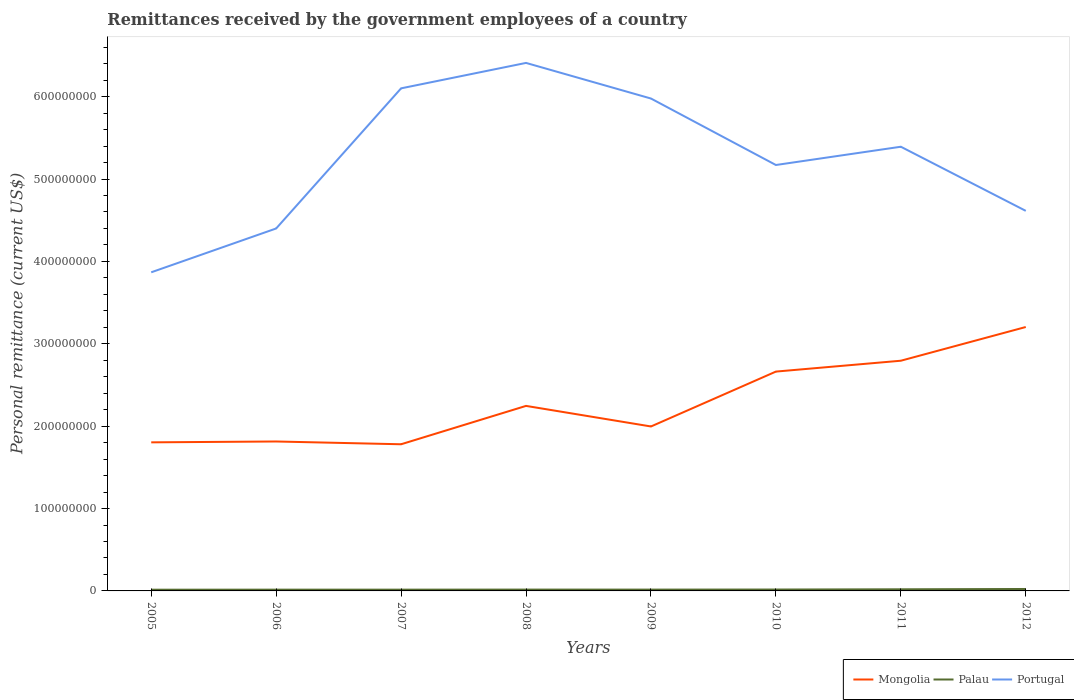How many different coloured lines are there?
Your response must be concise. 3. Across all years, what is the maximum remittances received by the government employees in Palau?
Your answer should be compact. 1.47e+06. What is the total remittances received by the government employees in Mongolia in the graph?
Give a very brief answer. 3.36e+06. What is the difference between the highest and the second highest remittances received by the government employees in Portugal?
Your answer should be compact. 2.54e+08. Is the remittances received by the government employees in Mongolia strictly greater than the remittances received by the government employees in Palau over the years?
Offer a terse response. No. What is the difference between two consecutive major ticks on the Y-axis?
Offer a terse response. 1.00e+08. Are the values on the major ticks of Y-axis written in scientific E-notation?
Offer a very short reply. No. Where does the legend appear in the graph?
Ensure brevity in your answer.  Bottom right. What is the title of the graph?
Keep it short and to the point. Remittances received by the government employees of a country. What is the label or title of the Y-axis?
Provide a short and direct response. Personal remittance (current US$). What is the Personal remittance (current US$) in Mongolia in 2005?
Provide a short and direct response. 1.80e+08. What is the Personal remittance (current US$) of Palau in 2005?
Offer a very short reply. 1.47e+06. What is the Personal remittance (current US$) of Portugal in 2005?
Make the answer very short. 3.87e+08. What is the Personal remittance (current US$) in Mongolia in 2006?
Offer a terse response. 1.81e+08. What is the Personal remittance (current US$) of Palau in 2006?
Make the answer very short. 1.54e+06. What is the Personal remittance (current US$) of Portugal in 2006?
Provide a short and direct response. 4.40e+08. What is the Personal remittance (current US$) of Mongolia in 2007?
Keep it short and to the point. 1.78e+08. What is the Personal remittance (current US$) in Palau in 2007?
Ensure brevity in your answer.  1.53e+06. What is the Personal remittance (current US$) in Portugal in 2007?
Your answer should be compact. 6.10e+08. What is the Personal remittance (current US$) in Mongolia in 2008?
Your answer should be very brief. 2.25e+08. What is the Personal remittance (current US$) of Palau in 2008?
Give a very brief answer. 1.60e+06. What is the Personal remittance (current US$) in Portugal in 2008?
Provide a succinct answer. 6.41e+08. What is the Personal remittance (current US$) of Mongolia in 2009?
Your response must be concise. 2.00e+08. What is the Personal remittance (current US$) in Palau in 2009?
Offer a terse response. 1.59e+06. What is the Personal remittance (current US$) of Portugal in 2009?
Your answer should be compact. 5.98e+08. What is the Personal remittance (current US$) of Mongolia in 2010?
Offer a terse response. 2.66e+08. What is the Personal remittance (current US$) of Palau in 2010?
Ensure brevity in your answer.  1.69e+06. What is the Personal remittance (current US$) of Portugal in 2010?
Your answer should be compact. 5.17e+08. What is the Personal remittance (current US$) of Mongolia in 2011?
Make the answer very short. 2.79e+08. What is the Personal remittance (current US$) in Palau in 2011?
Your response must be concise. 1.97e+06. What is the Personal remittance (current US$) of Portugal in 2011?
Provide a succinct answer. 5.39e+08. What is the Personal remittance (current US$) of Mongolia in 2012?
Your answer should be compact. 3.20e+08. What is the Personal remittance (current US$) of Palau in 2012?
Your response must be concise. 2.36e+06. What is the Personal remittance (current US$) in Portugal in 2012?
Your response must be concise. 4.61e+08. Across all years, what is the maximum Personal remittance (current US$) in Mongolia?
Your answer should be compact. 3.20e+08. Across all years, what is the maximum Personal remittance (current US$) of Palau?
Ensure brevity in your answer.  2.36e+06. Across all years, what is the maximum Personal remittance (current US$) in Portugal?
Keep it short and to the point. 6.41e+08. Across all years, what is the minimum Personal remittance (current US$) in Mongolia?
Give a very brief answer. 1.78e+08. Across all years, what is the minimum Personal remittance (current US$) of Palau?
Give a very brief answer. 1.47e+06. Across all years, what is the minimum Personal remittance (current US$) of Portugal?
Give a very brief answer. 3.87e+08. What is the total Personal remittance (current US$) of Mongolia in the graph?
Ensure brevity in your answer.  1.83e+09. What is the total Personal remittance (current US$) of Palau in the graph?
Offer a terse response. 1.38e+07. What is the total Personal remittance (current US$) of Portugal in the graph?
Offer a terse response. 4.19e+09. What is the difference between the Personal remittance (current US$) of Mongolia in 2005 and that in 2006?
Your answer should be compact. -1.03e+06. What is the difference between the Personal remittance (current US$) in Palau in 2005 and that in 2006?
Provide a succinct answer. -6.72e+04. What is the difference between the Personal remittance (current US$) in Portugal in 2005 and that in 2006?
Make the answer very short. -5.32e+07. What is the difference between the Personal remittance (current US$) of Mongolia in 2005 and that in 2007?
Provide a short and direct response. 2.33e+06. What is the difference between the Personal remittance (current US$) in Palau in 2005 and that in 2007?
Your answer should be compact. -5.45e+04. What is the difference between the Personal remittance (current US$) in Portugal in 2005 and that in 2007?
Make the answer very short. -2.23e+08. What is the difference between the Personal remittance (current US$) of Mongolia in 2005 and that in 2008?
Your response must be concise. -4.42e+07. What is the difference between the Personal remittance (current US$) in Palau in 2005 and that in 2008?
Give a very brief answer. -1.30e+05. What is the difference between the Personal remittance (current US$) of Portugal in 2005 and that in 2008?
Your answer should be very brief. -2.54e+08. What is the difference between the Personal remittance (current US$) of Mongolia in 2005 and that in 2009?
Keep it short and to the point. -1.93e+07. What is the difference between the Personal remittance (current US$) in Palau in 2005 and that in 2009?
Offer a terse response. -1.16e+05. What is the difference between the Personal remittance (current US$) in Portugal in 2005 and that in 2009?
Give a very brief answer. -2.11e+08. What is the difference between the Personal remittance (current US$) of Mongolia in 2005 and that in 2010?
Give a very brief answer. -8.59e+07. What is the difference between the Personal remittance (current US$) in Palau in 2005 and that in 2010?
Ensure brevity in your answer.  -2.10e+05. What is the difference between the Personal remittance (current US$) in Portugal in 2005 and that in 2010?
Provide a short and direct response. -1.30e+08. What is the difference between the Personal remittance (current US$) of Mongolia in 2005 and that in 2011?
Offer a very short reply. -9.91e+07. What is the difference between the Personal remittance (current US$) in Palau in 2005 and that in 2011?
Provide a succinct answer. -4.92e+05. What is the difference between the Personal remittance (current US$) in Portugal in 2005 and that in 2011?
Provide a succinct answer. -1.52e+08. What is the difference between the Personal remittance (current US$) in Mongolia in 2005 and that in 2012?
Make the answer very short. -1.40e+08. What is the difference between the Personal remittance (current US$) in Palau in 2005 and that in 2012?
Ensure brevity in your answer.  -8.85e+05. What is the difference between the Personal remittance (current US$) of Portugal in 2005 and that in 2012?
Your answer should be compact. -7.46e+07. What is the difference between the Personal remittance (current US$) in Mongolia in 2006 and that in 2007?
Give a very brief answer. 3.36e+06. What is the difference between the Personal remittance (current US$) in Palau in 2006 and that in 2007?
Provide a short and direct response. 1.27e+04. What is the difference between the Personal remittance (current US$) in Portugal in 2006 and that in 2007?
Keep it short and to the point. -1.70e+08. What is the difference between the Personal remittance (current US$) of Mongolia in 2006 and that in 2008?
Provide a short and direct response. -4.32e+07. What is the difference between the Personal remittance (current US$) in Palau in 2006 and that in 2008?
Provide a short and direct response. -6.25e+04. What is the difference between the Personal remittance (current US$) in Portugal in 2006 and that in 2008?
Your answer should be compact. -2.01e+08. What is the difference between the Personal remittance (current US$) of Mongolia in 2006 and that in 2009?
Your answer should be very brief. -1.82e+07. What is the difference between the Personal remittance (current US$) of Palau in 2006 and that in 2009?
Give a very brief answer. -4.83e+04. What is the difference between the Personal remittance (current US$) of Portugal in 2006 and that in 2009?
Make the answer very short. -1.58e+08. What is the difference between the Personal remittance (current US$) in Mongolia in 2006 and that in 2010?
Your response must be concise. -8.49e+07. What is the difference between the Personal remittance (current US$) of Palau in 2006 and that in 2010?
Your answer should be very brief. -1.43e+05. What is the difference between the Personal remittance (current US$) of Portugal in 2006 and that in 2010?
Offer a terse response. -7.71e+07. What is the difference between the Personal remittance (current US$) of Mongolia in 2006 and that in 2011?
Offer a terse response. -9.80e+07. What is the difference between the Personal remittance (current US$) in Palau in 2006 and that in 2011?
Keep it short and to the point. -4.25e+05. What is the difference between the Personal remittance (current US$) in Portugal in 2006 and that in 2011?
Keep it short and to the point. -9.92e+07. What is the difference between the Personal remittance (current US$) of Mongolia in 2006 and that in 2012?
Your answer should be very brief. -1.39e+08. What is the difference between the Personal remittance (current US$) in Palau in 2006 and that in 2012?
Make the answer very short. -8.18e+05. What is the difference between the Personal remittance (current US$) of Portugal in 2006 and that in 2012?
Your answer should be compact. -2.14e+07. What is the difference between the Personal remittance (current US$) in Mongolia in 2007 and that in 2008?
Give a very brief answer. -4.66e+07. What is the difference between the Personal remittance (current US$) of Palau in 2007 and that in 2008?
Keep it short and to the point. -7.51e+04. What is the difference between the Personal remittance (current US$) in Portugal in 2007 and that in 2008?
Provide a succinct answer. -3.09e+07. What is the difference between the Personal remittance (current US$) in Mongolia in 2007 and that in 2009?
Ensure brevity in your answer.  -2.16e+07. What is the difference between the Personal remittance (current US$) of Palau in 2007 and that in 2009?
Your response must be concise. -6.10e+04. What is the difference between the Personal remittance (current US$) in Portugal in 2007 and that in 2009?
Give a very brief answer. 1.24e+07. What is the difference between the Personal remittance (current US$) of Mongolia in 2007 and that in 2010?
Your response must be concise. -8.82e+07. What is the difference between the Personal remittance (current US$) of Palau in 2007 and that in 2010?
Your answer should be compact. -1.56e+05. What is the difference between the Personal remittance (current US$) in Portugal in 2007 and that in 2010?
Provide a short and direct response. 9.31e+07. What is the difference between the Personal remittance (current US$) of Mongolia in 2007 and that in 2011?
Your answer should be compact. -1.01e+08. What is the difference between the Personal remittance (current US$) in Palau in 2007 and that in 2011?
Offer a very short reply. -4.38e+05. What is the difference between the Personal remittance (current US$) of Portugal in 2007 and that in 2011?
Give a very brief answer. 7.09e+07. What is the difference between the Personal remittance (current US$) of Mongolia in 2007 and that in 2012?
Your response must be concise. -1.42e+08. What is the difference between the Personal remittance (current US$) in Palau in 2007 and that in 2012?
Offer a very short reply. -8.31e+05. What is the difference between the Personal remittance (current US$) in Portugal in 2007 and that in 2012?
Offer a terse response. 1.49e+08. What is the difference between the Personal remittance (current US$) of Mongolia in 2008 and that in 2009?
Ensure brevity in your answer.  2.50e+07. What is the difference between the Personal remittance (current US$) in Palau in 2008 and that in 2009?
Give a very brief answer. 1.41e+04. What is the difference between the Personal remittance (current US$) of Portugal in 2008 and that in 2009?
Ensure brevity in your answer.  4.32e+07. What is the difference between the Personal remittance (current US$) of Mongolia in 2008 and that in 2010?
Give a very brief answer. -4.16e+07. What is the difference between the Personal remittance (current US$) of Palau in 2008 and that in 2010?
Ensure brevity in your answer.  -8.08e+04. What is the difference between the Personal remittance (current US$) of Portugal in 2008 and that in 2010?
Keep it short and to the point. 1.24e+08. What is the difference between the Personal remittance (current US$) of Mongolia in 2008 and that in 2011?
Provide a short and direct response. -5.48e+07. What is the difference between the Personal remittance (current US$) in Palau in 2008 and that in 2011?
Offer a terse response. -3.63e+05. What is the difference between the Personal remittance (current US$) of Portugal in 2008 and that in 2011?
Provide a short and direct response. 1.02e+08. What is the difference between the Personal remittance (current US$) in Mongolia in 2008 and that in 2012?
Give a very brief answer. -9.58e+07. What is the difference between the Personal remittance (current US$) of Palau in 2008 and that in 2012?
Your answer should be very brief. -7.56e+05. What is the difference between the Personal remittance (current US$) in Portugal in 2008 and that in 2012?
Provide a succinct answer. 1.80e+08. What is the difference between the Personal remittance (current US$) of Mongolia in 2009 and that in 2010?
Provide a succinct answer. -6.66e+07. What is the difference between the Personal remittance (current US$) of Palau in 2009 and that in 2010?
Ensure brevity in your answer.  -9.49e+04. What is the difference between the Personal remittance (current US$) of Portugal in 2009 and that in 2010?
Keep it short and to the point. 8.07e+07. What is the difference between the Personal remittance (current US$) in Mongolia in 2009 and that in 2011?
Give a very brief answer. -7.98e+07. What is the difference between the Personal remittance (current US$) in Palau in 2009 and that in 2011?
Your response must be concise. -3.77e+05. What is the difference between the Personal remittance (current US$) in Portugal in 2009 and that in 2011?
Provide a succinct answer. 5.85e+07. What is the difference between the Personal remittance (current US$) of Mongolia in 2009 and that in 2012?
Ensure brevity in your answer.  -1.21e+08. What is the difference between the Personal remittance (current US$) of Palau in 2009 and that in 2012?
Your answer should be very brief. -7.70e+05. What is the difference between the Personal remittance (current US$) of Portugal in 2009 and that in 2012?
Provide a short and direct response. 1.36e+08. What is the difference between the Personal remittance (current US$) of Mongolia in 2010 and that in 2011?
Keep it short and to the point. -1.32e+07. What is the difference between the Personal remittance (current US$) in Palau in 2010 and that in 2011?
Provide a succinct answer. -2.82e+05. What is the difference between the Personal remittance (current US$) in Portugal in 2010 and that in 2011?
Your answer should be compact. -2.22e+07. What is the difference between the Personal remittance (current US$) of Mongolia in 2010 and that in 2012?
Keep it short and to the point. -5.41e+07. What is the difference between the Personal remittance (current US$) of Palau in 2010 and that in 2012?
Ensure brevity in your answer.  -6.75e+05. What is the difference between the Personal remittance (current US$) in Portugal in 2010 and that in 2012?
Provide a short and direct response. 5.57e+07. What is the difference between the Personal remittance (current US$) of Mongolia in 2011 and that in 2012?
Give a very brief answer. -4.09e+07. What is the difference between the Personal remittance (current US$) in Palau in 2011 and that in 2012?
Your answer should be compact. -3.93e+05. What is the difference between the Personal remittance (current US$) in Portugal in 2011 and that in 2012?
Give a very brief answer. 7.78e+07. What is the difference between the Personal remittance (current US$) in Mongolia in 2005 and the Personal remittance (current US$) in Palau in 2006?
Provide a succinct answer. 1.79e+08. What is the difference between the Personal remittance (current US$) of Mongolia in 2005 and the Personal remittance (current US$) of Portugal in 2006?
Give a very brief answer. -2.60e+08. What is the difference between the Personal remittance (current US$) in Palau in 2005 and the Personal remittance (current US$) in Portugal in 2006?
Ensure brevity in your answer.  -4.38e+08. What is the difference between the Personal remittance (current US$) of Mongolia in 2005 and the Personal remittance (current US$) of Palau in 2007?
Offer a very short reply. 1.79e+08. What is the difference between the Personal remittance (current US$) in Mongolia in 2005 and the Personal remittance (current US$) in Portugal in 2007?
Offer a terse response. -4.30e+08. What is the difference between the Personal remittance (current US$) of Palau in 2005 and the Personal remittance (current US$) of Portugal in 2007?
Offer a terse response. -6.09e+08. What is the difference between the Personal remittance (current US$) in Mongolia in 2005 and the Personal remittance (current US$) in Palau in 2008?
Provide a short and direct response. 1.79e+08. What is the difference between the Personal remittance (current US$) in Mongolia in 2005 and the Personal remittance (current US$) in Portugal in 2008?
Give a very brief answer. -4.61e+08. What is the difference between the Personal remittance (current US$) in Palau in 2005 and the Personal remittance (current US$) in Portugal in 2008?
Give a very brief answer. -6.39e+08. What is the difference between the Personal remittance (current US$) in Mongolia in 2005 and the Personal remittance (current US$) in Palau in 2009?
Provide a succinct answer. 1.79e+08. What is the difference between the Personal remittance (current US$) in Mongolia in 2005 and the Personal remittance (current US$) in Portugal in 2009?
Provide a succinct answer. -4.17e+08. What is the difference between the Personal remittance (current US$) in Palau in 2005 and the Personal remittance (current US$) in Portugal in 2009?
Your answer should be very brief. -5.96e+08. What is the difference between the Personal remittance (current US$) in Mongolia in 2005 and the Personal remittance (current US$) in Palau in 2010?
Offer a terse response. 1.79e+08. What is the difference between the Personal remittance (current US$) of Mongolia in 2005 and the Personal remittance (current US$) of Portugal in 2010?
Give a very brief answer. -3.37e+08. What is the difference between the Personal remittance (current US$) in Palau in 2005 and the Personal remittance (current US$) in Portugal in 2010?
Your answer should be very brief. -5.16e+08. What is the difference between the Personal remittance (current US$) of Mongolia in 2005 and the Personal remittance (current US$) of Palau in 2011?
Your answer should be compact. 1.78e+08. What is the difference between the Personal remittance (current US$) of Mongolia in 2005 and the Personal remittance (current US$) of Portugal in 2011?
Offer a very short reply. -3.59e+08. What is the difference between the Personal remittance (current US$) of Palau in 2005 and the Personal remittance (current US$) of Portugal in 2011?
Provide a succinct answer. -5.38e+08. What is the difference between the Personal remittance (current US$) of Mongolia in 2005 and the Personal remittance (current US$) of Palau in 2012?
Offer a terse response. 1.78e+08. What is the difference between the Personal remittance (current US$) of Mongolia in 2005 and the Personal remittance (current US$) of Portugal in 2012?
Ensure brevity in your answer.  -2.81e+08. What is the difference between the Personal remittance (current US$) in Palau in 2005 and the Personal remittance (current US$) in Portugal in 2012?
Offer a very short reply. -4.60e+08. What is the difference between the Personal remittance (current US$) of Mongolia in 2006 and the Personal remittance (current US$) of Palau in 2007?
Ensure brevity in your answer.  1.80e+08. What is the difference between the Personal remittance (current US$) of Mongolia in 2006 and the Personal remittance (current US$) of Portugal in 2007?
Offer a terse response. -4.29e+08. What is the difference between the Personal remittance (current US$) of Palau in 2006 and the Personal remittance (current US$) of Portugal in 2007?
Keep it short and to the point. -6.09e+08. What is the difference between the Personal remittance (current US$) of Mongolia in 2006 and the Personal remittance (current US$) of Palau in 2008?
Your answer should be compact. 1.80e+08. What is the difference between the Personal remittance (current US$) in Mongolia in 2006 and the Personal remittance (current US$) in Portugal in 2008?
Ensure brevity in your answer.  -4.60e+08. What is the difference between the Personal remittance (current US$) in Palau in 2006 and the Personal remittance (current US$) in Portugal in 2008?
Ensure brevity in your answer.  -6.39e+08. What is the difference between the Personal remittance (current US$) in Mongolia in 2006 and the Personal remittance (current US$) in Palau in 2009?
Make the answer very short. 1.80e+08. What is the difference between the Personal remittance (current US$) in Mongolia in 2006 and the Personal remittance (current US$) in Portugal in 2009?
Ensure brevity in your answer.  -4.16e+08. What is the difference between the Personal remittance (current US$) of Palau in 2006 and the Personal remittance (current US$) of Portugal in 2009?
Provide a succinct answer. -5.96e+08. What is the difference between the Personal remittance (current US$) in Mongolia in 2006 and the Personal remittance (current US$) in Palau in 2010?
Your response must be concise. 1.80e+08. What is the difference between the Personal remittance (current US$) in Mongolia in 2006 and the Personal remittance (current US$) in Portugal in 2010?
Give a very brief answer. -3.36e+08. What is the difference between the Personal remittance (current US$) of Palau in 2006 and the Personal remittance (current US$) of Portugal in 2010?
Give a very brief answer. -5.15e+08. What is the difference between the Personal remittance (current US$) of Mongolia in 2006 and the Personal remittance (current US$) of Palau in 2011?
Keep it short and to the point. 1.79e+08. What is the difference between the Personal remittance (current US$) in Mongolia in 2006 and the Personal remittance (current US$) in Portugal in 2011?
Your response must be concise. -3.58e+08. What is the difference between the Personal remittance (current US$) of Palau in 2006 and the Personal remittance (current US$) of Portugal in 2011?
Give a very brief answer. -5.38e+08. What is the difference between the Personal remittance (current US$) in Mongolia in 2006 and the Personal remittance (current US$) in Palau in 2012?
Make the answer very short. 1.79e+08. What is the difference between the Personal remittance (current US$) in Mongolia in 2006 and the Personal remittance (current US$) in Portugal in 2012?
Ensure brevity in your answer.  -2.80e+08. What is the difference between the Personal remittance (current US$) in Palau in 2006 and the Personal remittance (current US$) in Portugal in 2012?
Provide a short and direct response. -4.60e+08. What is the difference between the Personal remittance (current US$) of Mongolia in 2007 and the Personal remittance (current US$) of Palau in 2008?
Provide a succinct answer. 1.76e+08. What is the difference between the Personal remittance (current US$) of Mongolia in 2007 and the Personal remittance (current US$) of Portugal in 2008?
Your response must be concise. -4.63e+08. What is the difference between the Personal remittance (current US$) in Palau in 2007 and the Personal remittance (current US$) in Portugal in 2008?
Offer a very short reply. -6.39e+08. What is the difference between the Personal remittance (current US$) of Mongolia in 2007 and the Personal remittance (current US$) of Palau in 2009?
Your answer should be compact. 1.76e+08. What is the difference between the Personal remittance (current US$) of Mongolia in 2007 and the Personal remittance (current US$) of Portugal in 2009?
Your answer should be compact. -4.20e+08. What is the difference between the Personal remittance (current US$) of Palau in 2007 and the Personal remittance (current US$) of Portugal in 2009?
Your answer should be compact. -5.96e+08. What is the difference between the Personal remittance (current US$) of Mongolia in 2007 and the Personal remittance (current US$) of Palau in 2010?
Give a very brief answer. 1.76e+08. What is the difference between the Personal remittance (current US$) in Mongolia in 2007 and the Personal remittance (current US$) in Portugal in 2010?
Your answer should be compact. -3.39e+08. What is the difference between the Personal remittance (current US$) of Palau in 2007 and the Personal remittance (current US$) of Portugal in 2010?
Make the answer very short. -5.15e+08. What is the difference between the Personal remittance (current US$) of Mongolia in 2007 and the Personal remittance (current US$) of Palau in 2011?
Provide a succinct answer. 1.76e+08. What is the difference between the Personal remittance (current US$) of Mongolia in 2007 and the Personal remittance (current US$) of Portugal in 2011?
Your answer should be very brief. -3.61e+08. What is the difference between the Personal remittance (current US$) in Palau in 2007 and the Personal remittance (current US$) in Portugal in 2011?
Provide a succinct answer. -5.38e+08. What is the difference between the Personal remittance (current US$) of Mongolia in 2007 and the Personal remittance (current US$) of Palau in 2012?
Provide a short and direct response. 1.76e+08. What is the difference between the Personal remittance (current US$) in Mongolia in 2007 and the Personal remittance (current US$) in Portugal in 2012?
Keep it short and to the point. -2.83e+08. What is the difference between the Personal remittance (current US$) of Palau in 2007 and the Personal remittance (current US$) of Portugal in 2012?
Give a very brief answer. -4.60e+08. What is the difference between the Personal remittance (current US$) in Mongolia in 2008 and the Personal remittance (current US$) in Palau in 2009?
Give a very brief answer. 2.23e+08. What is the difference between the Personal remittance (current US$) of Mongolia in 2008 and the Personal remittance (current US$) of Portugal in 2009?
Provide a succinct answer. -3.73e+08. What is the difference between the Personal remittance (current US$) of Palau in 2008 and the Personal remittance (current US$) of Portugal in 2009?
Give a very brief answer. -5.96e+08. What is the difference between the Personal remittance (current US$) of Mongolia in 2008 and the Personal remittance (current US$) of Palau in 2010?
Make the answer very short. 2.23e+08. What is the difference between the Personal remittance (current US$) of Mongolia in 2008 and the Personal remittance (current US$) of Portugal in 2010?
Your answer should be compact. -2.92e+08. What is the difference between the Personal remittance (current US$) of Palau in 2008 and the Personal remittance (current US$) of Portugal in 2010?
Offer a terse response. -5.15e+08. What is the difference between the Personal remittance (current US$) of Mongolia in 2008 and the Personal remittance (current US$) of Palau in 2011?
Keep it short and to the point. 2.23e+08. What is the difference between the Personal remittance (current US$) in Mongolia in 2008 and the Personal remittance (current US$) in Portugal in 2011?
Offer a very short reply. -3.15e+08. What is the difference between the Personal remittance (current US$) of Palau in 2008 and the Personal remittance (current US$) of Portugal in 2011?
Your response must be concise. -5.38e+08. What is the difference between the Personal remittance (current US$) in Mongolia in 2008 and the Personal remittance (current US$) in Palau in 2012?
Your response must be concise. 2.22e+08. What is the difference between the Personal remittance (current US$) of Mongolia in 2008 and the Personal remittance (current US$) of Portugal in 2012?
Your answer should be compact. -2.37e+08. What is the difference between the Personal remittance (current US$) of Palau in 2008 and the Personal remittance (current US$) of Portugal in 2012?
Provide a succinct answer. -4.60e+08. What is the difference between the Personal remittance (current US$) of Mongolia in 2009 and the Personal remittance (current US$) of Palau in 2010?
Make the answer very short. 1.98e+08. What is the difference between the Personal remittance (current US$) in Mongolia in 2009 and the Personal remittance (current US$) in Portugal in 2010?
Give a very brief answer. -3.17e+08. What is the difference between the Personal remittance (current US$) in Palau in 2009 and the Personal remittance (current US$) in Portugal in 2010?
Provide a short and direct response. -5.15e+08. What is the difference between the Personal remittance (current US$) in Mongolia in 2009 and the Personal remittance (current US$) in Palau in 2011?
Provide a short and direct response. 1.98e+08. What is the difference between the Personal remittance (current US$) in Mongolia in 2009 and the Personal remittance (current US$) in Portugal in 2011?
Ensure brevity in your answer.  -3.40e+08. What is the difference between the Personal remittance (current US$) of Palau in 2009 and the Personal remittance (current US$) of Portugal in 2011?
Provide a succinct answer. -5.38e+08. What is the difference between the Personal remittance (current US$) in Mongolia in 2009 and the Personal remittance (current US$) in Palau in 2012?
Offer a very short reply. 1.97e+08. What is the difference between the Personal remittance (current US$) in Mongolia in 2009 and the Personal remittance (current US$) in Portugal in 2012?
Provide a short and direct response. -2.62e+08. What is the difference between the Personal remittance (current US$) of Palau in 2009 and the Personal remittance (current US$) of Portugal in 2012?
Provide a short and direct response. -4.60e+08. What is the difference between the Personal remittance (current US$) of Mongolia in 2010 and the Personal remittance (current US$) of Palau in 2011?
Ensure brevity in your answer.  2.64e+08. What is the difference between the Personal remittance (current US$) of Mongolia in 2010 and the Personal remittance (current US$) of Portugal in 2011?
Your answer should be compact. -2.73e+08. What is the difference between the Personal remittance (current US$) of Palau in 2010 and the Personal remittance (current US$) of Portugal in 2011?
Your response must be concise. -5.38e+08. What is the difference between the Personal remittance (current US$) of Mongolia in 2010 and the Personal remittance (current US$) of Palau in 2012?
Keep it short and to the point. 2.64e+08. What is the difference between the Personal remittance (current US$) of Mongolia in 2010 and the Personal remittance (current US$) of Portugal in 2012?
Provide a short and direct response. -1.95e+08. What is the difference between the Personal remittance (current US$) of Palau in 2010 and the Personal remittance (current US$) of Portugal in 2012?
Your answer should be very brief. -4.60e+08. What is the difference between the Personal remittance (current US$) of Mongolia in 2011 and the Personal remittance (current US$) of Palau in 2012?
Provide a short and direct response. 2.77e+08. What is the difference between the Personal remittance (current US$) in Mongolia in 2011 and the Personal remittance (current US$) in Portugal in 2012?
Your answer should be compact. -1.82e+08. What is the difference between the Personal remittance (current US$) of Palau in 2011 and the Personal remittance (current US$) of Portugal in 2012?
Keep it short and to the point. -4.59e+08. What is the average Personal remittance (current US$) of Mongolia per year?
Your response must be concise. 2.29e+08. What is the average Personal remittance (current US$) in Palau per year?
Offer a terse response. 1.72e+06. What is the average Personal remittance (current US$) of Portugal per year?
Provide a short and direct response. 5.24e+08. In the year 2005, what is the difference between the Personal remittance (current US$) in Mongolia and Personal remittance (current US$) in Palau?
Provide a succinct answer. 1.79e+08. In the year 2005, what is the difference between the Personal remittance (current US$) of Mongolia and Personal remittance (current US$) of Portugal?
Your answer should be compact. -2.06e+08. In the year 2005, what is the difference between the Personal remittance (current US$) of Palau and Personal remittance (current US$) of Portugal?
Your answer should be very brief. -3.85e+08. In the year 2006, what is the difference between the Personal remittance (current US$) of Mongolia and Personal remittance (current US$) of Palau?
Provide a succinct answer. 1.80e+08. In the year 2006, what is the difference between the Personal remittance (current US$) in Mongolia and Personal remittance (current US$) in Portugal?
Keep it short and to the point. -2.59e+08. In the year 2006, what is the difference between the Personal remittance (current US$) in Palau and Personal remittance (current US$) in Portugal?
Your response must be concise. -4.38e+08. In the year 2007, what is the difference between the Personal remittance (current US$) of Mongolia and Personal remittance (current US$) of Palau?
Offer a very short reply. 1.77e+08. In the year 2007, what is the difference between the Personal remittance (current US$) in Mongolia and Personal remittance (current US$) in Portugal?
Ensure brevity in your answer.  -4.32e+08. In the year 2007, what is the difference between the Personal remittance (current US$) in Palau and Personal remittance (current US$) in Portugal?
Offer a terse response. -6.09e+08. In the year 2008, what is the difference between the Personal remittance (current US$) of Mongolia and Personal remittance (current US$) of Palau?
Make the answer very short. 2.23e+08. In the year 2008, what is the difference between the Personal remittance (current US$) of Mongolia and Personal remittance (current US$) of Portugal?
Keep it short and to the point. -4.16e+08. In the year 2008, what is the difference between the Personal remittance (current US$) in Palau and Personal remittance (current US$) in Portugal?
Ensure brevity in your answer.  -6.39e+08. In the year 2009, what is the difference between the Personal remittance (current US$) of Mongolia and Personal remittance (current US$) of Palau?
Make the answer very short. 1.98e+08. In the year 2009, what is the difference between the Personal remittance (current US$) of Mongolia and Personal remittance (current US$) of Portugal?
Your answer should be compact. -3.98e+08. In the year 2009, what is the difference between the Personal remittance (current US$) of Palau and Personal remittance (current US$) of Portugal?
Offer a terse response. -5.96e+08. In the year 2010, what is the difference between the Personal remittance (current US$) in Mongolia and Personal remittance (current US$) in Palau?
Your response must be concise. 2.65e+08. In the year 2010, what is the difference between the Personal remittance (current US$) in Mongolia and Personal remittance (current US$) in Portugal?
Your answer should be compact. -2.51e+08. In the year 2010, what is the difference between the Personal remittance (current US$) of Palau and Personal remittance (current US$) of Portugal?
Provide a succinct answer. -5.15e+08. In the year 2011, what is the difference between the Personal remittance (current US$) of Mongolia and Personal remittance (current US$) of Palau?
Ensure brevity in your answer.  2.77e+08. In the year 2011, what is the difference between the Personal remittance (current US$) in Mongolia and Personal remittance (current US$) in Portugal?
Your answer should be very brief. -2.60e+08. In the year 2011, what is the difference between the Personal remittance (current US$) of Palau and Personal remittance (current US$) of Portugal?
Give a very brief answer. -5.37e+08. In the year 2012, what is the difference between the Personal remittance (current US$) of Mongolia and Personal remittance (current US$) of Palau?
Provide a succinct answer. 3.18e+08. In the year 2012, what is the difference between the Personal remittance (current US$) of Mongolia and Personal remittance (current US$) of Portugal?
Your answer should be very brief. -1.41e+08. In the year 2012, what is the difference between the Personal remittance (current US$) of Palau and Personal remittance (current US$) of Portugal?
Offer a terse response. -4.59e+08. What is the ratio of the Personal remittance (current US$) in Mongolia in 2005 to that in 2006?
Provide a succinct answer. 0.99. What is the ratio of the Personal remittance (current US$) of Palau in 2005 to that in 2006?
Give a very brief answer. 0.96. What is the ratio of the Personal remittance (current US$) of Portugal in 2005 to that in 2006?
Offer a terse response. 0.88. What is the ratio of the Personal remittance (current US$) in Mongolia in 2005 to that in 2007?
Give a very brief answer. 1.01. What is the ratio of the Personal remittance (current US$) of Palau in 2005 to that in 2007?
Provide a short and direct response. 0.96. What is the ratio of the Personal remittance (current US$) in Portugal in 2005 to that in 2007?
Keep it short and to the point. 0.63. What is the ratio of the Personal remittance (current US$) in Mongolia in 2005 to that in 2008?
Give a very brief answer. 0.8. What is the ratio of the Personal remittance (current US$) in Palau in 2005 to that in 2008?
Give a very brief answer. 0.92. What is the ratio of the Personal remittance (current US$) in Portugal in 2005 to that in 2008?
Keep it short and to the point. 0.6. What is the ratio of the Personal remittance (current US$) in Mongolia in 2005 to that in 2009?
Make the answer very short. 0.9. What is the ratio of the Personal remittance (current US$) of Palau in 2005 to that in 2009?
Offer a terse response. 0.93. What is the ratio of the Personal remittance (current US$) in Portugal in 2005 to that in 2009?
Your answer should be compact. 0.65. What is the ratio of the Personal remittance (current US$) of Mongolia in 2005 to that in 2010?
Provide a short and direct response. 0.68. What is the ratio of the Personal remittance (current US$) in Palau in 2005 to that in 2010?
Ensure brevity in your answer.  0.88. What is the ratio of the Personal remittance (current US$) in Portugal in 2005 to that in 2010?
Give a very brief answer. 0.75. What is the ratio of the Personal remittance (current US$) of Mongolia in 2005 to that in 2011?
Offer a very short reply. 0.65. What is the ratio of the Personal remittance (current US$) in Palau in 2005 to that in 2011?
Your response must be concise. 0.75. What is the ratio of the Personal remittance (current US$) in Portugal in 2005 to that in 2011?
Make the answer very short. 0.72. What is the ratio of the Personal remittance (current US$) of Mongolia in 2005 to that in 2012?
Your answer should be compact. 0.56. What is the ratio of the Personal remittance (current US$) of Palau in 2005 to that in 2012?
Offer a terse response. 0.62. What is the ratio of the Personal remittance (current US$) of Portugal in 2005 to that in 2012?
Your answer should be very brief. 0.84. What is the ratio of the Personal remittance (current US$) in Mongolia in 2006 to that in 2007?
Offer a terse response. 1.02. What is the ratio of the Personal remittance (current US$) in Palau in 2006 to that in 2007?
Provide a short and direct response. 1.01. What is the ratio of the Personal remittance (current US$) of Portugal in 2006 to that in 2007?
Your answer should be compact. 0.72. What is the ratio of the Personal remittance (current US$) in Mongolia in 2006 to that in 2008?
Ensure brevity in your answer.  0.81. What is the ratio of the Personal remittance (current US$) of Palau in 2006 to that in 2008?
Provide a short and direct response. 0.96. What is the ratio of the Personal remittance (current US$) in Portugal in 2006 to that in 2008?
Offer a terse response. 0.69. What is the ratio of the Personal remittance (current US$) in Mongolia in 2006 to that in 2009?
Your answer should be very brief. 0.91. What is the ratio of the Personal remittance (current US$) of Palau in 2006 to that in 2009?
Give a very brief answer. 0.97. What is the ratio of the Personal remittance (current US$) of Portugal in 2006 to that in 2009?
Provide a succinct answer. 0.74. What is the ratio of the Personal remittance (current US$) of Mongolia in 2006 to that in 2010?
Offer a terse response. 0.68. What is the ratio of the Personal remittance (current US$) in Palau in 2006 to that in 2010?
Keep it short and to the point. 0.92. What is the ratio of the Personal remittance (current US$) in Portugal in 2006 to that in 2010?
Ensure brevity in your answer.  0.85. What is the ratio of the Personal remittance (current US$) in Mongolia in 2006 to that in 2011?
Ensure brevity in your answer.  0.65. What is the ratio of the Personal remittance (current US$) in Palau in 2006 to that in 2011?
Your answer should be compact. 0.78. What is the ratio of the Personal remittance (current US$) in Portugal in 2006 to that in 2011?
Your answer should be compact. 0.82. What is the ratio of the Personal remittance (current US$) in Mongolia in 2006 to that in 2012?
Keep it short and to the point. 0.57. What is the ratio of the Personal remittance (current US$) of Palau in 2006 to that in 2012?
Offer a terse response. 0.65. What is the ratio of the Personal remittance (current US$) in Portugal in 2006 to that in 2012?
Offer a very short reply. 0.95. What is the ratio of the Personal remittance (current US$) of Mongolia in 2007 to that in 2008?
Your answer should be compact. 0.79. What is the ratio of the Personal remittance (current US$) in Palau in 2007 to that in 2008?
Provide a short and direct response. 0.95. What is the ratio of the Personal remittance (current US$) in Portugal in 2007 to that in 2008?
Your answer should be very brief. 0.95. What is the ratio of the Personal remittance (current US$) of Mongolia in 2007 to that in 2009?
Make the answer very short. 0.89. What is the ratio of the Personal remittance (current US$) in Palau in 2007 to that in 2009?
Give a very brief answer. 0.96. What is the ratio of the Personal remittance (current US$) of Portugal in 2007 to that in 2009?
Your answer should be compact. 1.02. What is the ratio of the Personal remittance (current US$) in Mongolia in 2007 to that in 2010?
Provide a short and direct response. 0.67. What is the ratio of the Personal remittance (current US$) in Palau in 2007 to that in 2010?
Provide a short and direct response. 0.91. What is the ratio of the Personal remittance (current US$) of Portugal in 2007 to that in 2010?
Provide a succinct answer. 1.18. What is the ratio of the Personal remittance (current US$) in Mongolia in 2007 to that in 2011?
Provide a succinct answer. 0.64. What is the ratio of the Personal remittance (current US$) in Palau in 2007 to that in 2011?
Ensure brevity in your answer.  0.78. What is the ratio of the Personal remittance (current US$) in Portugal in 2007 to that in 2011?
Provide a succinct answer. 1.13. What is the ratio of the Personal remittance (current US$) of Mongolia in 2007 to that in 2012?
Give a very brief answer. 0.56. What is the ratio of the Personal remittance (current US$) in Palau in 2007 to that in 2012?
Make the answer very short. 0.65. What is the ratio of the Personal remittance (current US$) in Portugal in 2007 to that in 2012?
Give a very brief answer. 1.32. What is the ratio of the Personal remittance (current US$) in Mongolia in 2008 to that in 2009?
Provide a short and direct response. 1.13. What is the ratio of the Personal remittance (current US$) of Palau in 2008 to that in 2009?
Offer a very short reply. 1.01. What is the ratio of the Personal remittance (current US$) in Portugal in 2008 to that in 2009?
Provide a short and direct response. 1.07. What is the ratio of the Personal remittance (current US$) of Mongolia in 2008 to that in 2010?
Make the answer very short. 0.84. What is the ratio of the Personal remittance (current US$) in Portugal in 2008 to that in 2010?
Provide a short and direct response. 1.24. What is the ratio of the Personal remittance (current US$) in Mongolia in 2008 to that in 2011?
Provide a short and direct response. 0.8. What is the ratio of the Personal remittance (current US$) in Palau in 2008 to that in 2011?
Ensure brevity in your answer.  0.82. What is the ratio of the Personal remittance (current US$) in Portugal in 2008 to that in 2011?
Your response must be concise. 1.19. What is the ratio of the Personal remittance (current US$) in Mongolia in 2008 to that in 2012?
Your response must be concise. 0.7. What is the ratio of the Personal remittance (current US$) in Palau in 2008 to that in 2012?
Make the answer very short. 0.68. What is the ratio of the Personal remittance (current US$) of Portugal in 2008 to that in 2012?
Your response must be concise. 1.39. What is the ratio of the Personal remittance (current US$) of Mongolia in 2009 to that in 2010?
Offer a very short reply. 0.75. What is the ratio of the Personal remittance (current US$) in Palau in 2009 to that in 2010?
Your answer should be very brief. 0.94. What is the ratio of the Personal remittance (current US$) in Portugal in 2009 to that in 2010?
Offer a terse response. 1.16. What is the ratio of the Personal remittance (current US$) in Mongolia in 2009 to that in 2011?
Offer a very short reply. 0.71. What is the ratio of the Personal remittance (current US$) of Palau in 2009 to that in 2011?
Keep it short and to the point. 0.81. What is the ratio of the Personal remittance (current US$) of Portugal in 2009 to that in 2011?
Your answer should be compact. 1.11. What is the ratio of the Personal remittance (current US$) in Mongolia in 2009 to that in 2012?
Your response must be concise. 0.62. What is the ratio of the Personal remittance (current US$) in Palau in 2009 to that in 2012?
Your answer should be very brief. 0.67. What is the ratio of the Personal remittance (current US$) in Portugal in 2009 to that in 2012?
Your answer should be very brief. 1.3. What is the ratio of the Personal remittance (current US$) in Mongolia in 2010 to that in 2011?
Keep it short and to the point. 0.95. What is the ratio of the Personal remittance (current US$) in Palau in 2010 to that in 2011?
Provide a succinct answer. 0.86. What is the ratio of the Personal remittance (current US$) in Portugal in 2010 to that in 2011?
Give a very brief answer. 0.96. What is the ratio of the Personal remittance (current US$) of Mongolia in 2010 to that in 2012?
Ensure brevity in your answer.  0.83. What is the ratio of the Personal remittance (current US$) of Palau in 2010 to that in 2012?
Your answer should be very brief. 0.71. What is the ratio of the Personal remittance (current US$) of Portugal in 2010 to that in 2012?
Provide a short and direct response. 1.12. What is the ratio of the Personal remittance (current US$) in Mongolia in 2011 to that in 2012?
Provide a short and direct response. 0.87. What is the ratio of the Personal remittance (current US$) of Palau in 2011 to that in 2012?
Give a very brief answer. 0.83. What is the ratio of the Personal remittance (current US$) of Portugal in 2011 to that in 2012?
Give a very brief answer. 1.17. What is the difference between the highest and the second highest Personal remittance (current US$) in Mongolia?
Your answer should be very brief. 4.09e+07. What is the difference between the highest and the second highest Personal remittance (current US$) of Palau?
Give a very brief answer. 3.93e+05. What is the difference between the highest and the second highest Personal remittance (current US$) of Portugal?
Your answer should be compact. 3.09e+07. What is the difference between the highest and the lowest Personal remittance (current US$) of Mongolia?
Offer a very short reply. 1.42e+08. What is the difference between the highest and the lowest Personal remittance (current US$) of Palau?
Make the answer very short. 8.85e+05. What is the difference between the highest and the lowest Personal remittance (current US$) in Portugal?
Offer a terse response. 2.54e+08. 